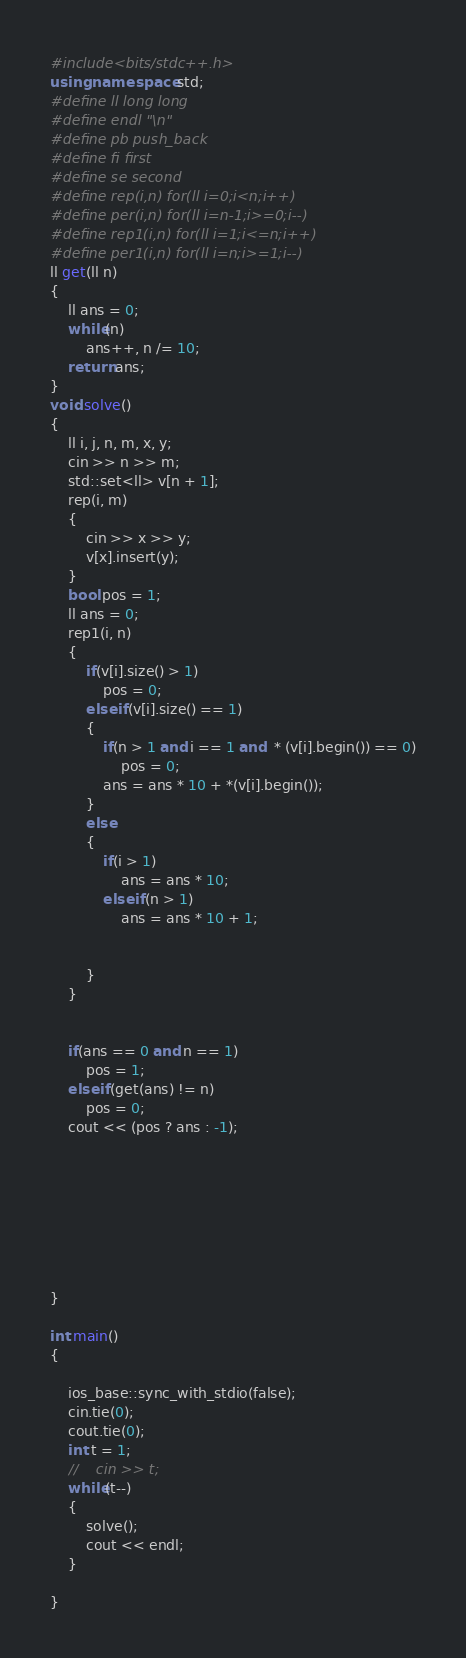<code> <loc_0><loc_0><loc_500><loc_500><_C++_>#include<bits/stdc++.h>
using namespace std;
#define ll long long
#define endl "\n"
#define pb push_back
#define fi first
#define se second
#define rep(i,n) for(ll i=0;i<n;i++)
#define per(i,n) for(ll i=n-1;i>=0;i--)
#define rep1(i,n) for(ll i=1;i<=n;i++)
#define per1(i,n) for(ll i=n;i>=1;i--)
ll get(ll n)
{
    ll ans = 0;
    while(n)
        ans++, n /= 10;
    return ans;
}
void solve()
{
    ll i, j, n, m, x, y;
    cin >> n >> m;
    std::set<ll> v[n + 1];
    rep(i, m)
    {
        cin >> x >> y;
        v[x].insert(y);
    }
    bool pos = 1;
    ll ans = 0;
    rep1(i, n)
    {
        if(v[i].size() > 1)
            pos = 0;
        else if(v[i].size() == 1)
        {
            if(n > 1 and i == 1 and  * (v[i].begin()) == 0)
                pos = 0;
            ans = ans * 10 + *(v[i].begin());
        }
        else
        {
            if(i > 1)
                ans = ans * 10;
            else if(n > 1)
                ans = ans * 10 + 1;


        }
    }


    if(ans == 0 and n == 1)
        pos = 1;
    else if(get(ans) != n)
        pos = 0;
    cout << (pos ? ans : -1);








}

int main()
{

    ios_base::sync_with_stdio(false);
    cin.tie(0);
    cout.tie(0);
    int t = 1;
    //    cin >> t;
    while(t--)
    {
        solve();
        cout << endl;
    }

}


</code> 